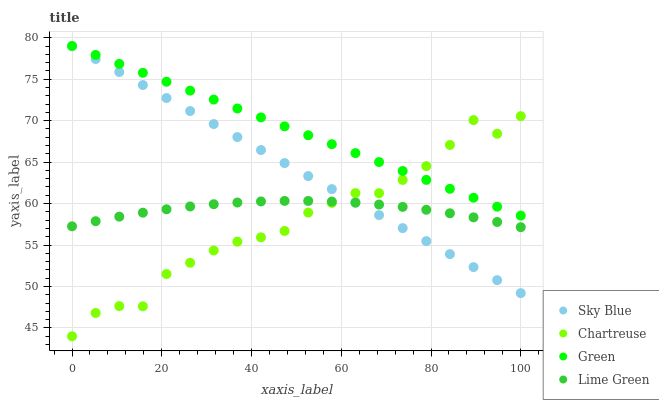Does Chartreuse have the minimum area under the curve?
Answer yes or no. Yes. Does Green have the maximum area under the curve?
Answer yes or no. Yes. Does Green have the minimum area under the curve?
Answer yes or no. No. Does Chartreuse have the maximum area under the curve?
Answer yes or no. No. Is Sky Blue the smoothest?
Answer yes or no. Yes. Is Chartreuse the roughest?
Answer yes or no. Yes. Is Green the smoothest?
Answer yes or no. No. Is Green the roughest?
Answer yes or no. No. Does Chartreuse have the lowest value?
Answer yes or no. Yes. Does Green have the lowest value?
Answer yes or no. No. Does Green have the highest value?
Answer yes or no. Yes. Does Chartreuse have the highest value?
Answer yes or no. No. Is Lime Green less than Green?
Answer yes or no. Yes. Is Green greater than Lime Green?
Answer yes or no. Yes. Does Lime Green intersect Sky Blue?
Answer yes or no. Yes. Is Lime Green less than Sky Blue?
Answer yes or no. No. Is Lime Green greater than Sky Blue?
Answer yes or no. No. Does Lime Green intersect Green?
Answer yes or no. No. 